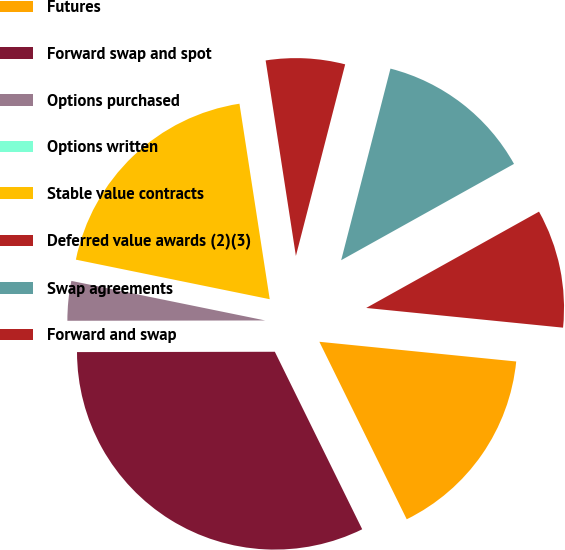Convert chart to OTSL. <chart><loc_0><loc_0><loc_500><loc_500><pie_chart><fcel>Futures<fcel>Forward swap and spot<fcel>Options purchased<fcel>Options written<fcel>Stable value contracts<fcel>Deferred value awards (2)(3)<fcel>Swap agreements<fcel>Forward and swap<nl><fcel>16.13%<fcel>32.25%<fcel>3.23%<fcel>0.0%<fcel>19.35%<fcel>6.45%<fcel>12.9%<fcel>9.68%<nl></chart> 